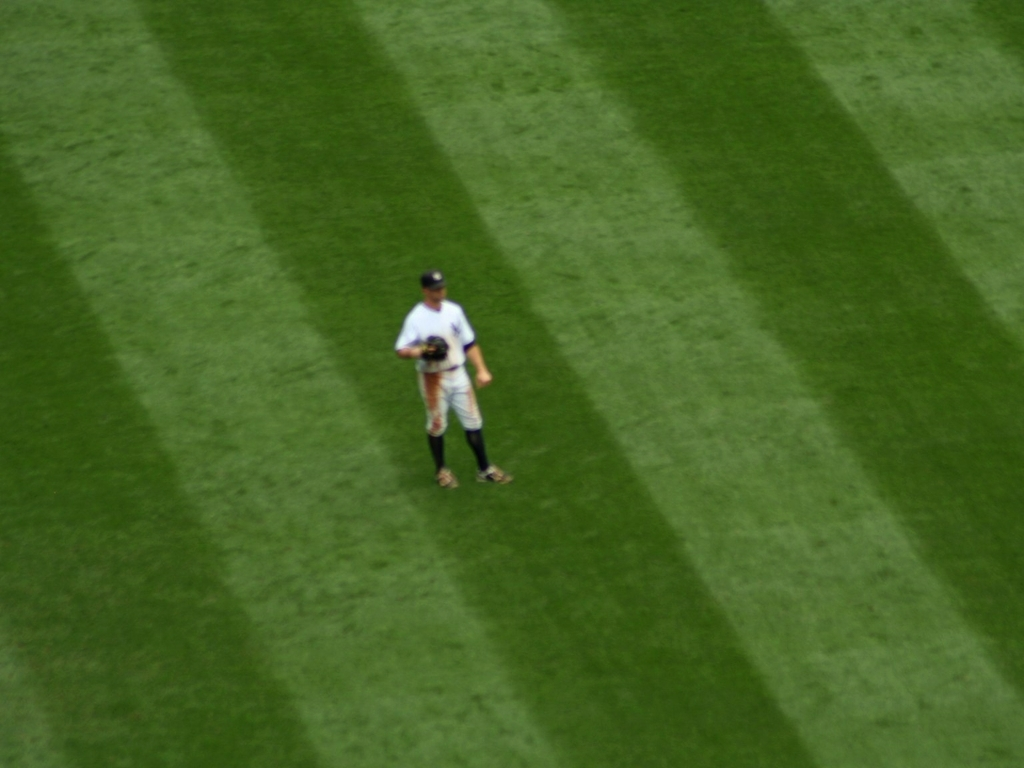What could be the reason for the striped pattern on the lawn? The striped pattern visible on the lawn is typically created by the mowing process. As a lawnmower moves over the grass, it bends the blades in the direction it travels. When the light reflects differently off the bent blades compared to the upright ones, it creates the alternating light and dark stripes we see. 